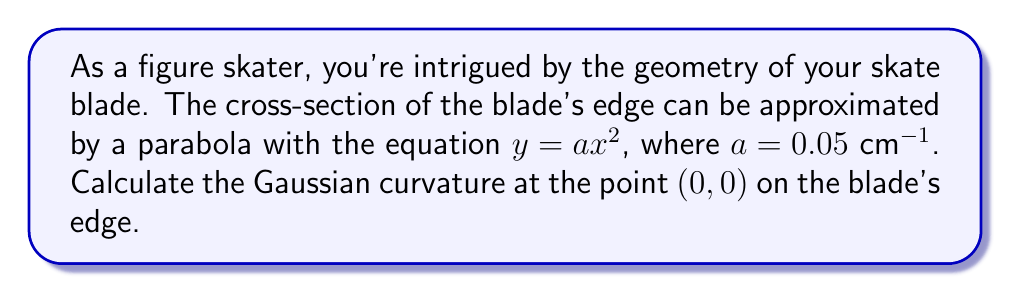Show me your answer to this math problem. To compute the Gaussian curvature of the skate blade's edge, we'll follow these steps:

1. The blade's edge is a ruled surface formed by extruding the parabola along a straight line. We can parameterize this surface as:

   $$S(u,v) = (u, av^2, v)$$

   where $u$ is the parameter along the length of the blade, and $v$ is the parameter across the blade's width.

2. To find the Gaussian curvature, we need to compute the coefficients of the first and second fundamental forms.

3. First, let's calculate the partial derivatives:
   
   $$S_u = (1, 0, 0)$$
   $$S_v = (0, 2av, 1)$$

4. The coefficients of the first fundamental form are:
   
   $$E = S_u \cdot S_u = 1$$
   $$F = S_u \cdot S_v = 0$$
   $$G = S_v \cdot S_v = 4a^2v^2 + 1$$

5. Now, let's calculate the second partial derivatives:
   
   $$S_{uu} = (0, 0, 0)$$
   $$S_{uv} = (0, 0, 0)$$
   $$S_{vv} = (0, 2a, 0)$$

6. The unit normal vector to the surface is:
   
   $$N = \frac{S_u \times S_v}{|S_u \times S_v|} = \frac{(-2av, 1, 0)}{\sqrt{4a^2v^2 + 1}}$$

7. The coefficients of the second fundamental form are:
   
   $$L = S_{uu} \cdot N = 0$$
   $$M = S_{uv} \cdot N = 0$$
   $$N = S_{vv} \cdot N = \frac{2a}{\sqrt{4a^2v^2 + 1}}$$

8. The Gaussian curvature is given by:
   
   $$K = \frac{LN - M^2}{EG - F^2}$$

9. Substituting the values at the point $(0,0)$:
   
   $$K = \frac{0 \cdot 2a - 0^2}{1 \cdot 1 - 0^2} = 0$$

Therefore, the Gaussian curvature at the point $(0,0)$ on the blade's edge is 0.
Answer: $K = 0$ 